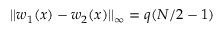Convert formula to latex. <formula><loc_0><loc_0><loc_500><loc_500>| | w _ { 1 } ( x ) - w _ { 2 } ( x ) | | _ { \infty } = q ( N / 2 - 1 )</formula> 